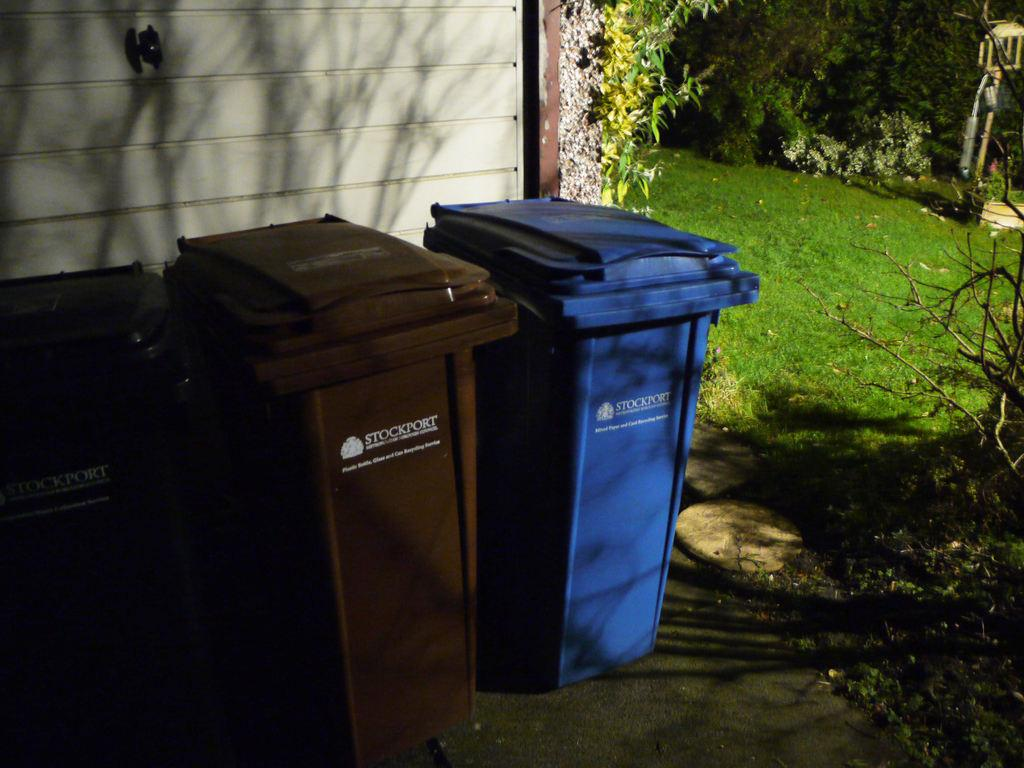<image>
Create a compact narrative representing the image presented. Blue and brown garbage cans that both says STOCKPORT on it. 